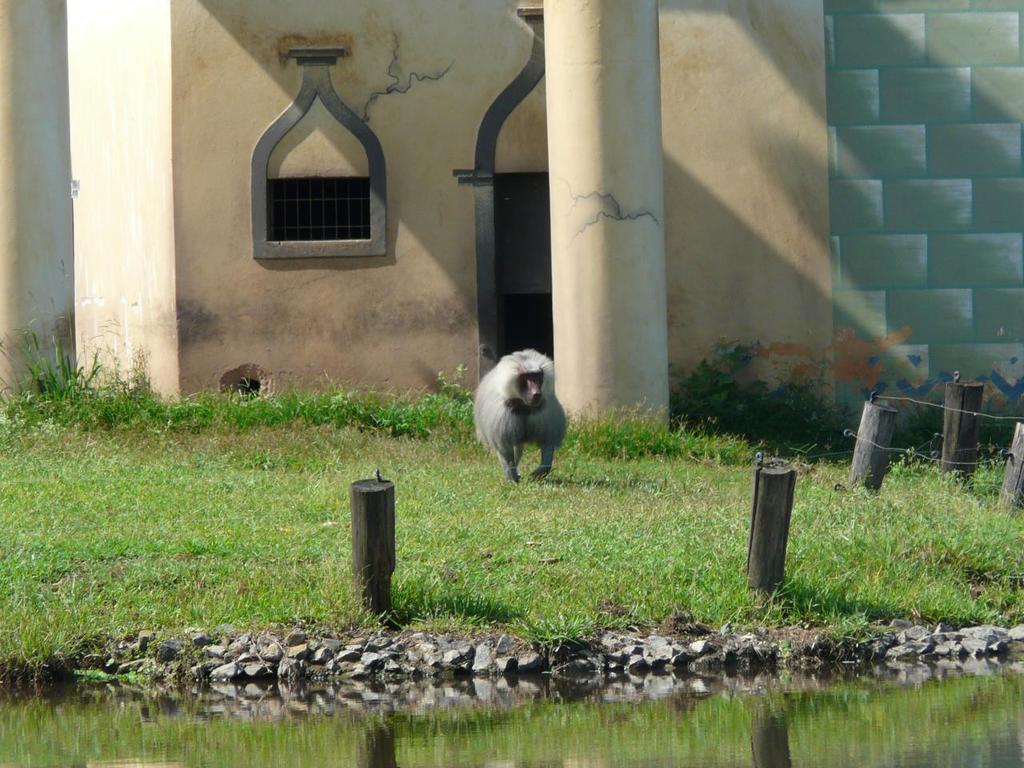Please provide a concise description of this image. In this picture I can see there is a monkey here and there is grass on the floor and there is a small pond here. In the backdrop there is a building and pillars. 